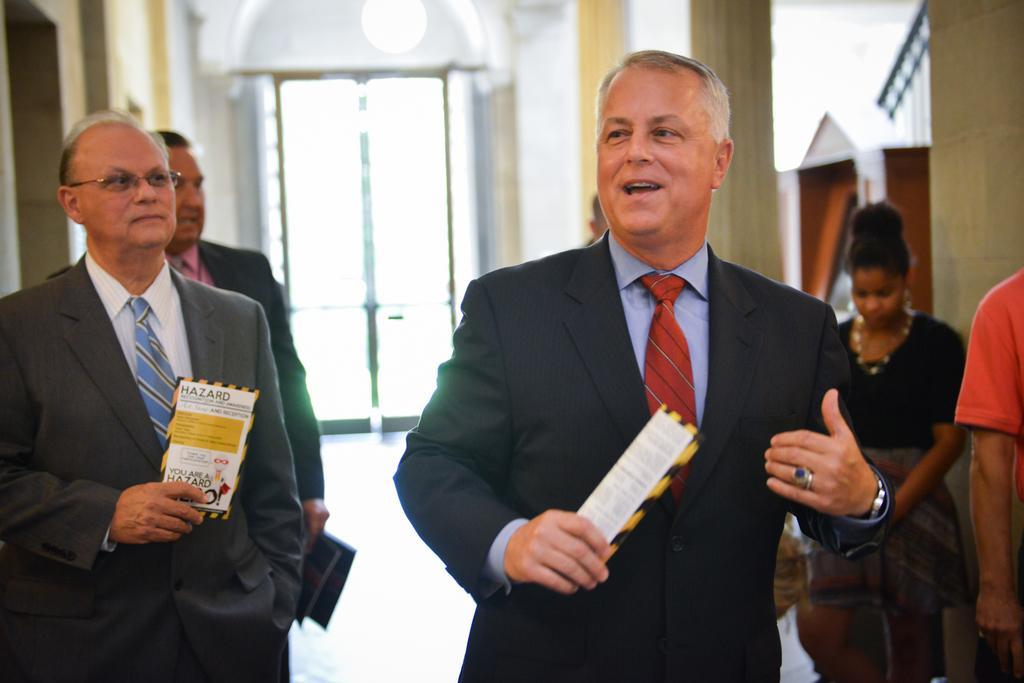Can you describe this image briefly? In this image there are people walking on the floor. They are holding papers in their hands. Beside them there are pillars and a wall. In the background there is a door. 